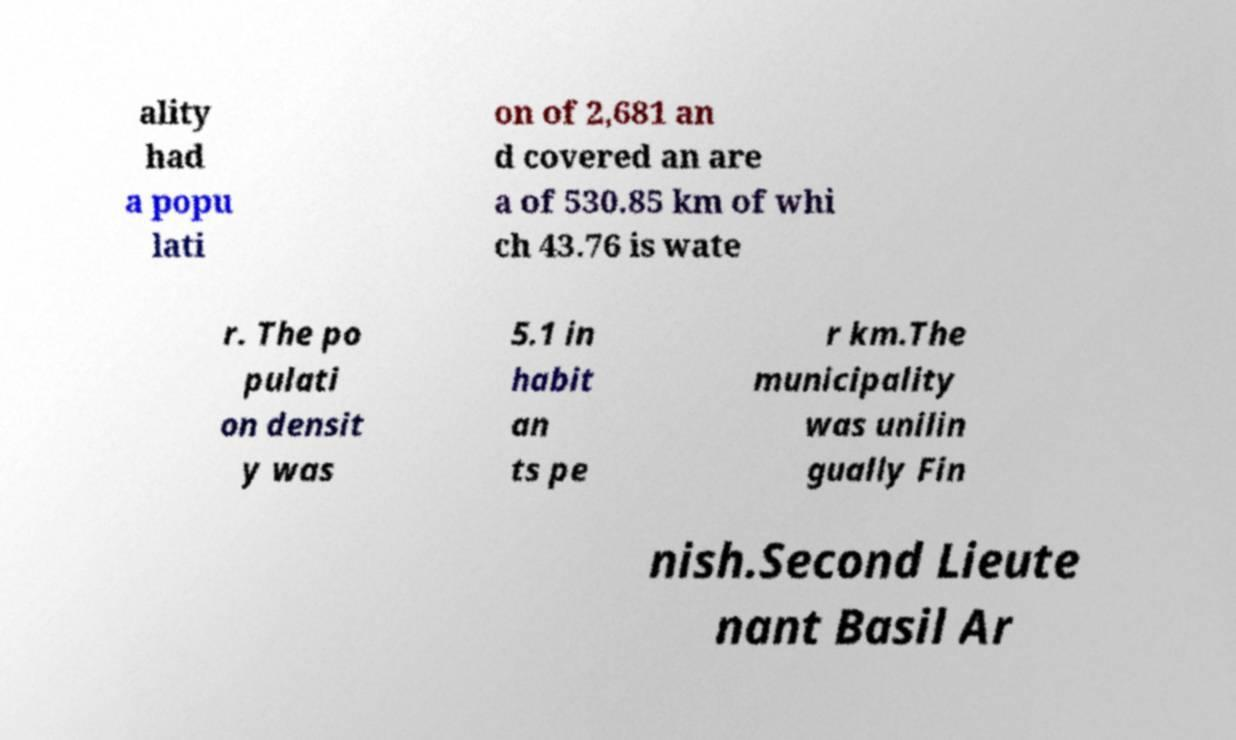Please read and relay the text visible in this image. What does it say? ality had a popu lati on of 2,681 an d covered an are a of 530.85 km of whi ch 43.76 is wate r. The po pulati on densit y was 5.1 in habit an ts pe r km.The municipality was unilin gually Fin nish.Second Lieute nant Basil Ar 